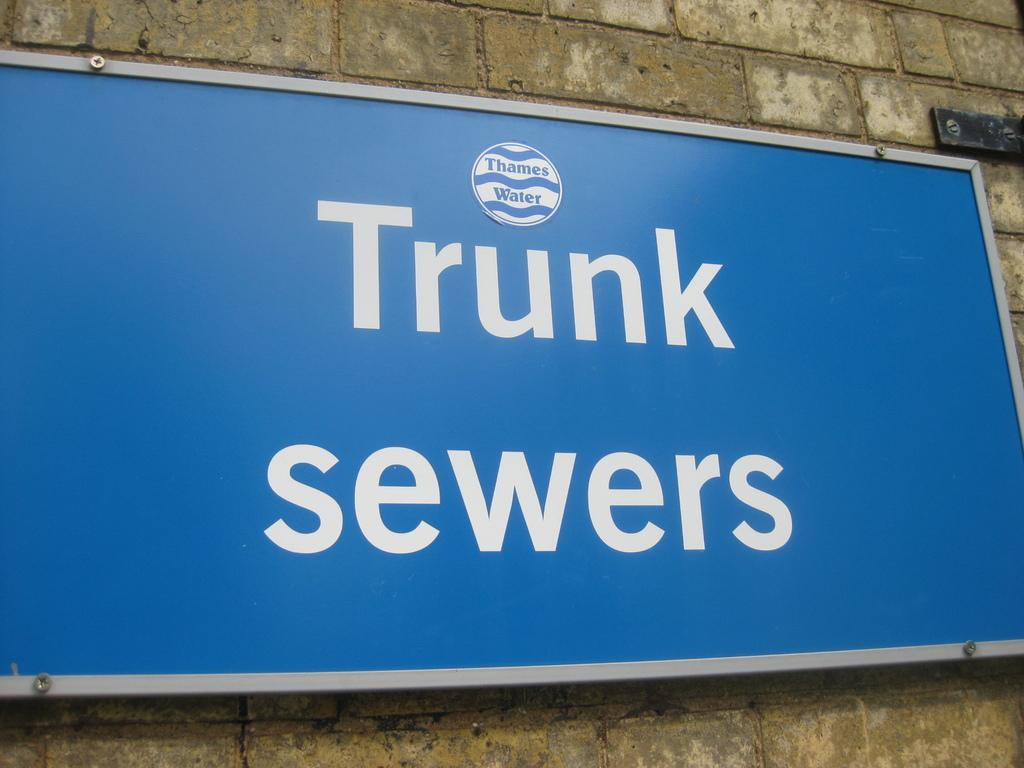<image>
Provide a brief description of the given image. A blue sign with white writing for Thames Water Trunk sewers is on a brick wall. 